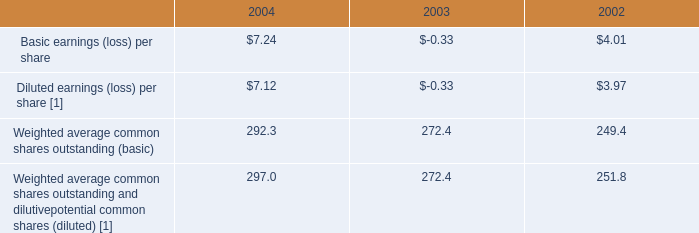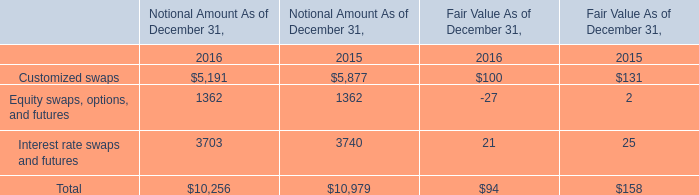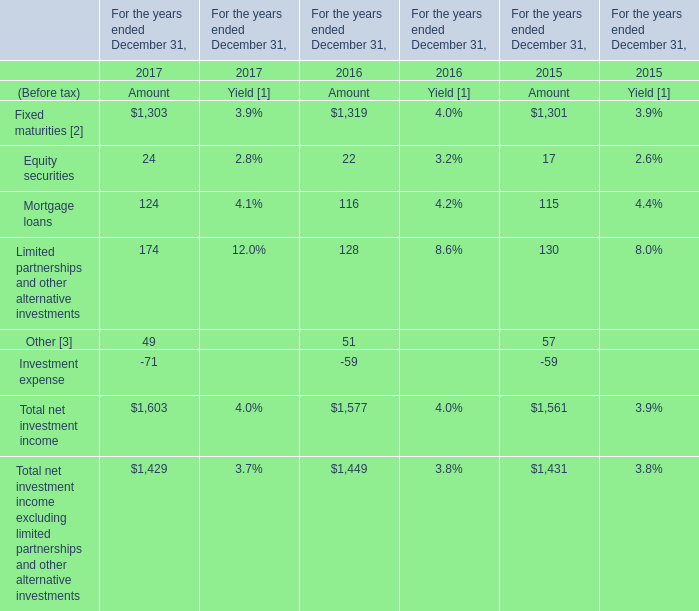What is the ratio of Equity securities to the total in 2017? 
Computations: (24 / 1603)
Answer: 0.01497. 